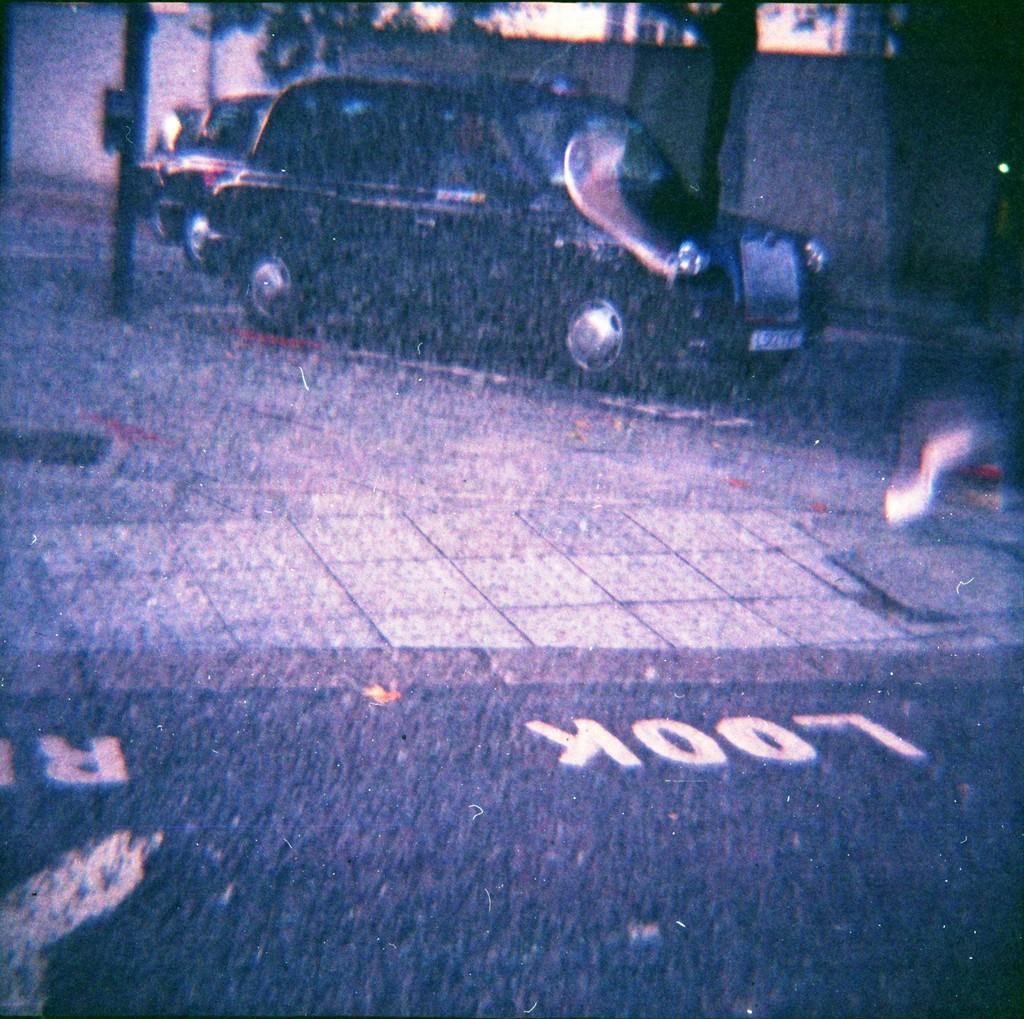What is located in the center of the image? There are vehicles in the center of the image. What can be seen in the image besides the vehicles? There is a pole in the image. What is visible in the background of the image? There is a wall and trees in the background of the image. What type of appliance is being used by the army in the image? There is no appliance or army present in the image. 